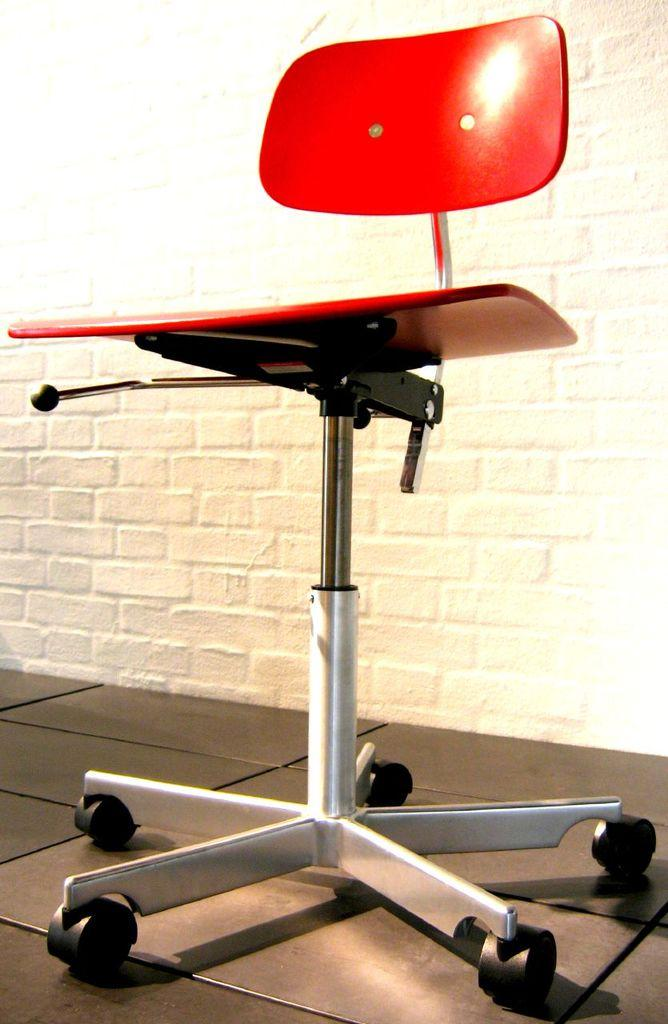What object is located in the foreground of the image? There is a chair in the foreground of the image. What can be seen in the background of the image? There is a wall in the background of the image. What type of sweater is draped over the chair in the image? There is no sweater present in the image; only a chair and a wall are visible. How does the grip of the chair handle appear in the image? The image does not show a close-up view of the chair handle, so it is not possible to describe the grip. 